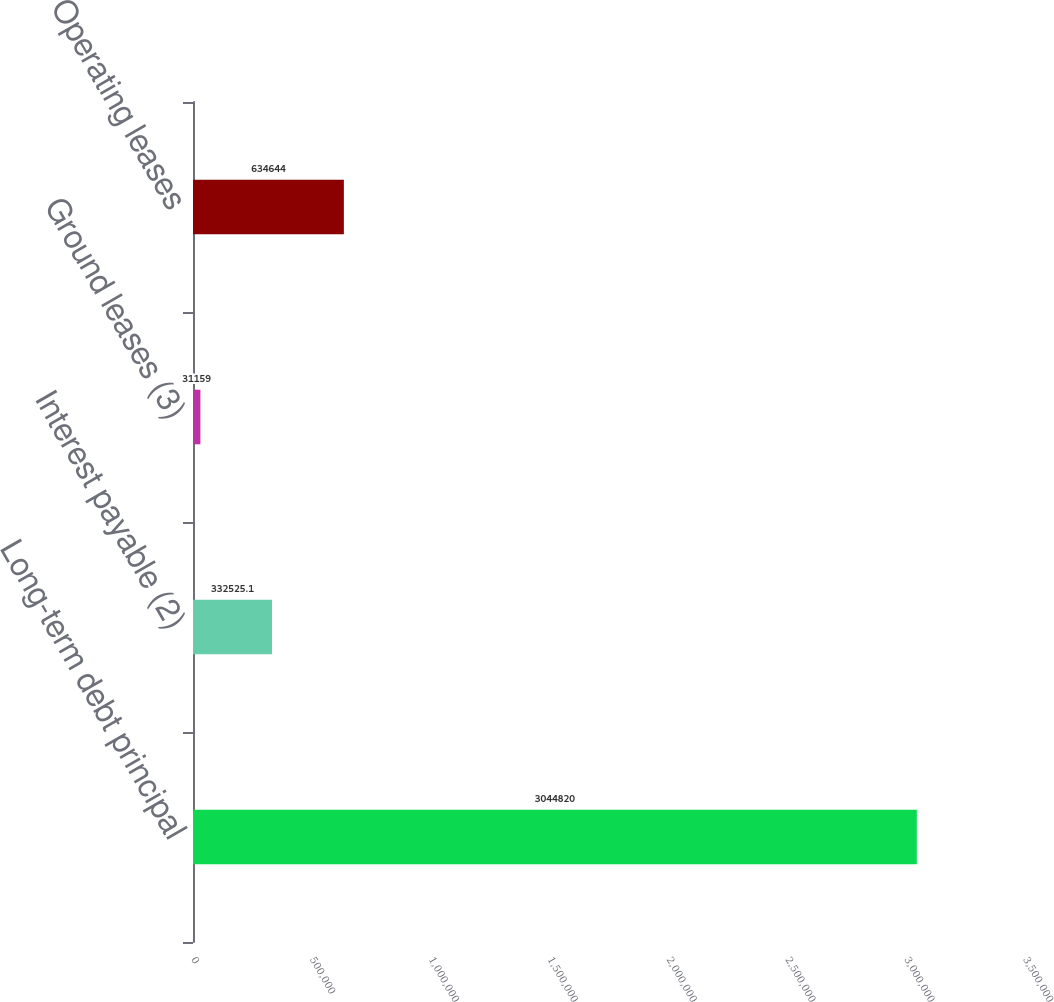<chart> <loc_0><loc_0><loc_500><loc_500><bar_chart><fcel>Long-term debt principal<fcel>Interest payable (2)<fcel>Ground leases (3)<fcel>Operating leases<nl><fcel>3.04482e+06<fcel>332525<fcel>31159<fcel>634644<nl></chart> 